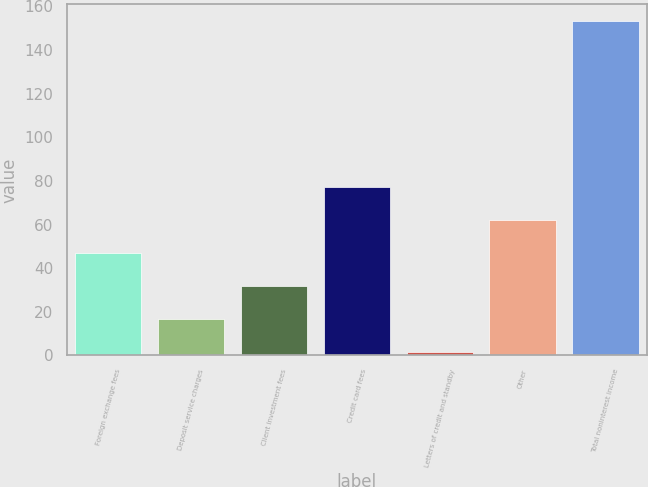Convert chart to OTSL. <chart><loc_0><loc_0><loc_500><loc_500><bar_chart><fcel>Foreign exchange fees<fcel>Deposit service charges<fcel>Client investment fees<fcel>Credit card fees<fcel>Letters of credit and standby<fcel>Other<fcel>Total noninterest income<nl><fcel>46.94<fcel>16.58<fcel>31.76<fcel>77.3<fcel>1.4<fcel>62.12<fcel>153.2<nl></chart> 